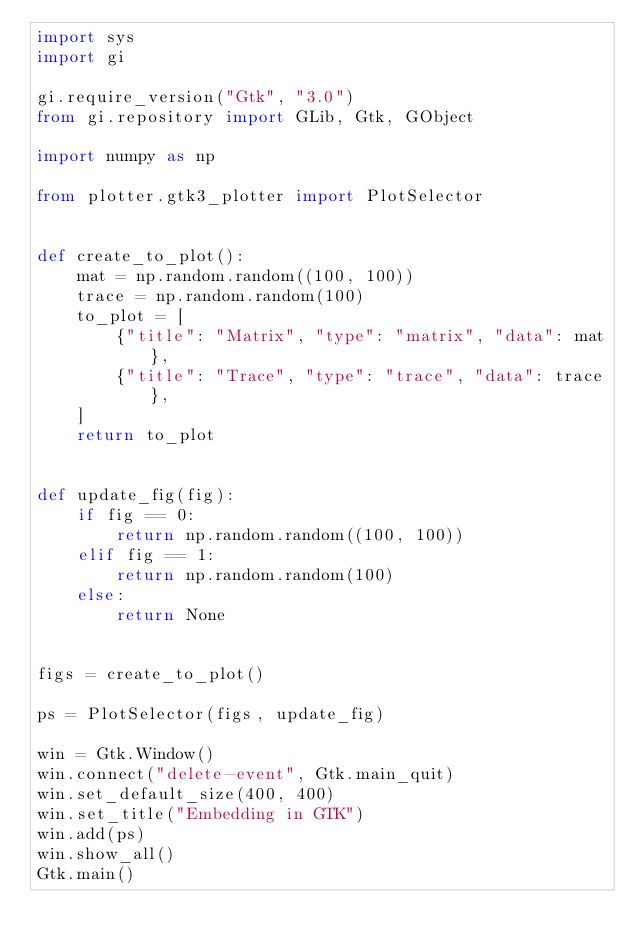Convert code to text. <code><loc_0><loc_0><loc_500><loc_500><_Python_>import sys
import gi

gi.require_version("Gtk", "3.0")
from gi.repository import GLib, Gtk, GObject

import numpy as np

from plotter.gtk3_plotter import PlotSelector


def create_to_plot():
    mat = np.random.random((100, 100))
    trace = np.random.random(100)
    to_plot = [
        {"title": "Matrix", "type": "matrix", "data": mat},
        {"title": "Trace", "type": "trace", "data": trace},
    ]
    return to_plot


def update_fig(fig):
    if fig == 0:
        return np.random.random((100, 100))
    elif fig == 1:
        return np.random.random(100)
    else:
        return None


figs = create_to_plot()

ps = PlotSelector(figs, update_fig)

win = Gtk.Window()
win.connect("delete-event", Gtk.main_quit)
win.set_default_size(400, 400)
win.set_title("Embedding in GTK")
win.add(ps)
win.show_all()
Gtk.main()
</code> 